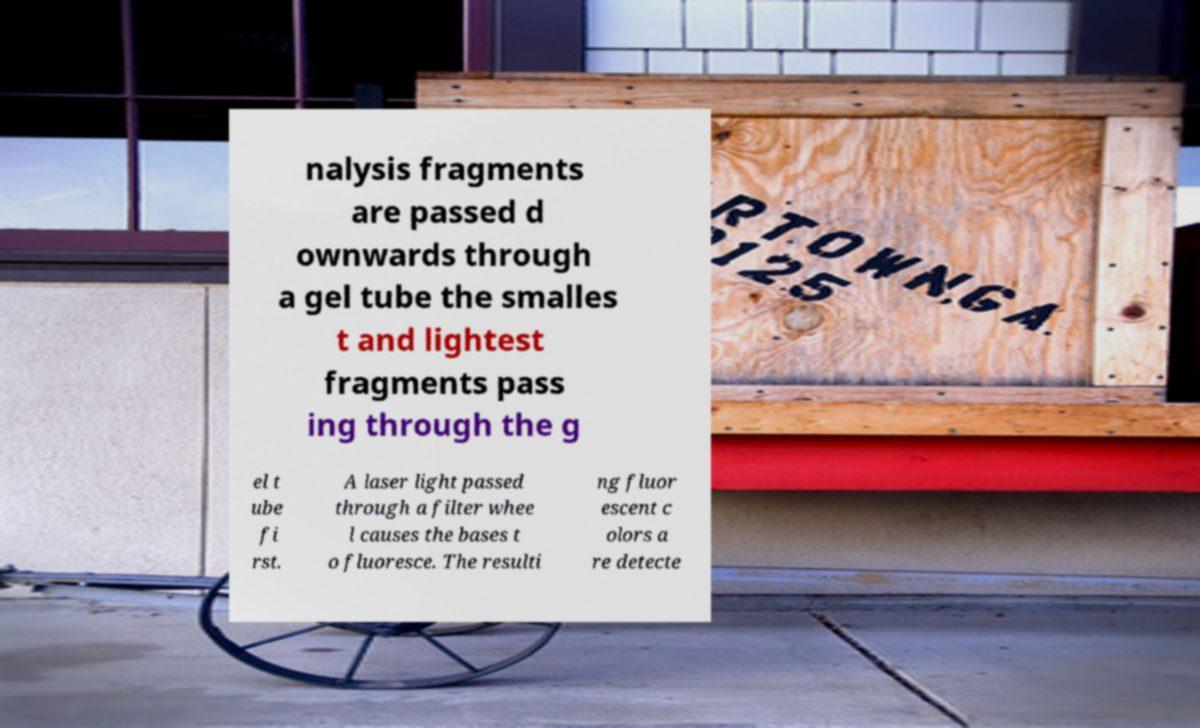Please read and relay the text visible in this image. What does it say? nalysis fragments are passed d ownwards through a gel tube the smalles t and lightest fragments pass ing through the g el t ube fi rst. A laser light passed through a filter whee l causes the bases t o fluoresce. The resulti ng fluor escent c olors a re detecte 